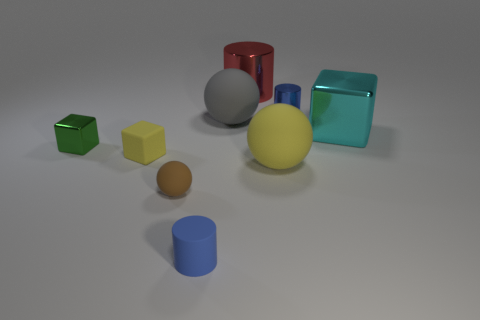There is a metal thing that is on the left side of the red metal cylinder; does it have the same size as the small yellow matte thing?
Your answer should be compact. Yes. What shape is the tiny object that is the same color as the small rubber cylinder?
Provide a succinct answer. Cylinder. How many cylinders are the same material as the green thing?
Make the answer very short. 2. The blue object left of the big red thing behind the metallic cube that is to the right of the tiny metallic cylinder is made of what material?
Offer a terse response. Rubber. The matte ball in front of the yellow sphere in front of the green block is what color?
Offer a very short reply. Brown. The ball that is the same size as the green metallic cube is what color?
Make the answer very short. Brown. How many tiny objects are red matte balls or gray things?
Your response must be concise. 0. Are there more gray matte things behind the big yellow thing than yellow rubber spheres right of the cyan metallic thing?
Keep it short and to the point. Yes. There is a ball that is the same color as the matte cube; what size is it?
Make the answer very short. Large. How many other things are there of the same size as the green metal block?
Provide a succinct answer. 4. 